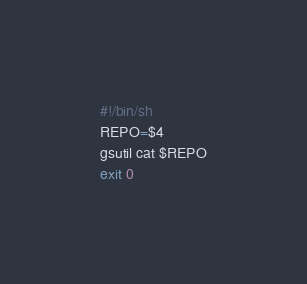Convert code to text. <code><loc_0><loc_0><loc_500><loc_500><_Bash_>#!/bin/sh
REPO=$4
gsutil cat $REPO
exit 0
</code> 